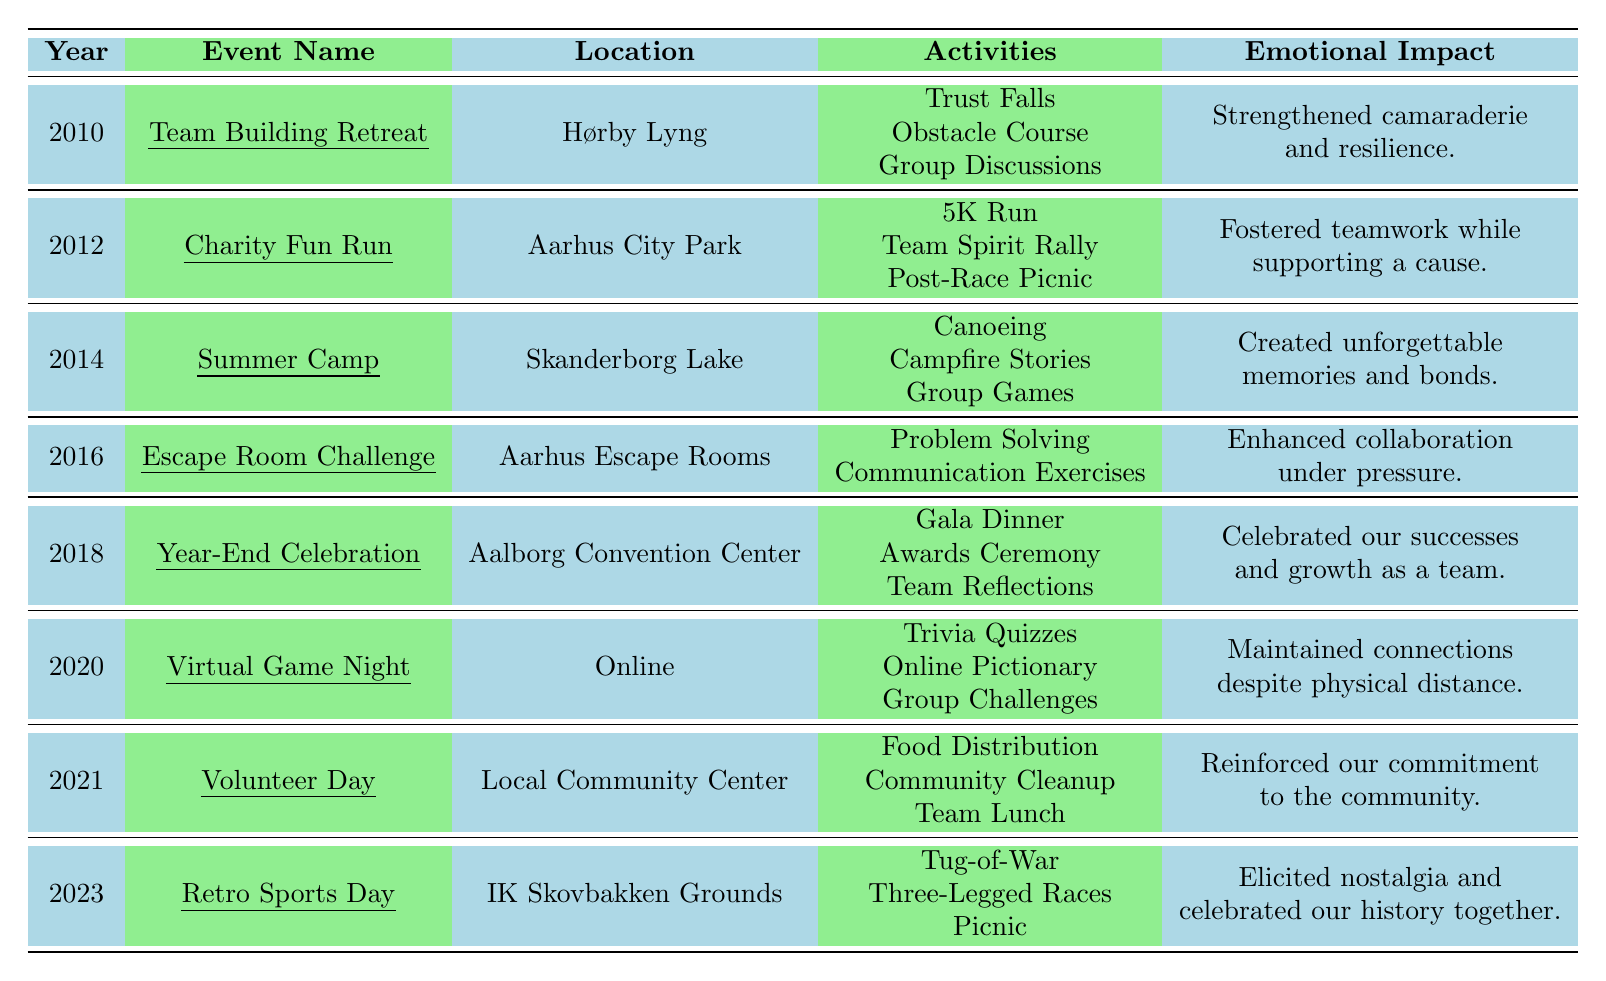What year did the "Summer Camp" event take place? The table shows that the "Summer Camp" event is listed under the year 2014.
Answer: 2014 Which event had the emotional impact "Strengthened camaraderie and resilience"? Referring to the emotional impact column, "Team Building Retreat" is associated with that impact, occurring in 2010.
Answer: Team Building Retreat What activities were included in the "Escape Room Challenge"? The activities listed under "Escape Room Challenge" are "Problem Solving" and "Communication Exercises."
Answer: Problem Solving, Communication Exercises How many team bonding events took place between 2010 and 2023? Counting the entries in the table from 2010 to 2023 gives a total of 8 events.
Answer: 8 Did any events occur in 2020? Yes, the "Virtual Game Night" occurred in 2020 according to the table.
Answer: Yes What is the emotional impact listed for the "Year-End Celebration"? The emotional impact stated for the "Year-End Celebration" is "Celebrated our successes and growth as a team."
Answer: Celebrated our successes and growth as a team What type of activities were featured in the 2023 event? The 2023 event, "Retro Sports Day," included activities like "Tug-of-War," "Three-Legged Races," and a "Picnic."
Answer: Tug-of-War, Three-Legged Races, Picnic If you combine the event years 2010, 2012, and 2014, what is their average year? The average is calculated by summing the years (2010 + 2012 + 2014 = 6036) and dividing by the number of years (3). So, 6036 / 3 = 2012.
Answer: 2012 Which event occurred in Aarhus City Park and what was its main activity? The event that took place in Aarhus City Park is the "Charity Fun Run," and its main activity was the "5K Run."
Answer: Charity Fun Run, 5K Run Was there a team bonding event focused on volunteering? Yes, the "Volunteer Day" in 2021 was focused on volunteering activities such as food distribution and community cleanup.
Answer: Yes Which year had a virtual bonding event due to physical distance? The year 2020 had the "Virtual Game Night," which was held online to maintain connections despite physical distance.
Answer: 2020 